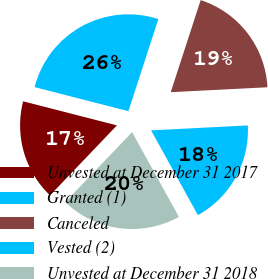Convert chart to OTSL. <chart><loc_0><loc_0><loc_500><loc_500><pie_chart><fcel>Unvested at December 31 2017<fcel>Granted (1)<fcel>Canceled<fcel>Vested (2)<fcel>Unvested at December 31 2018<nl><fcel>16.86%<fcel>26.01%<fcel>19.19%<fcel>17.78%<fcel>20.17%<nl></chart> 